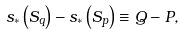<formula> <loc_0><loc_0><loc_500><loc_500>s _ { * } \left ( S _ { q } \right ) - s _ { * } \left ( S _ { p } \right ) \equiv Q - P ,</formula> 